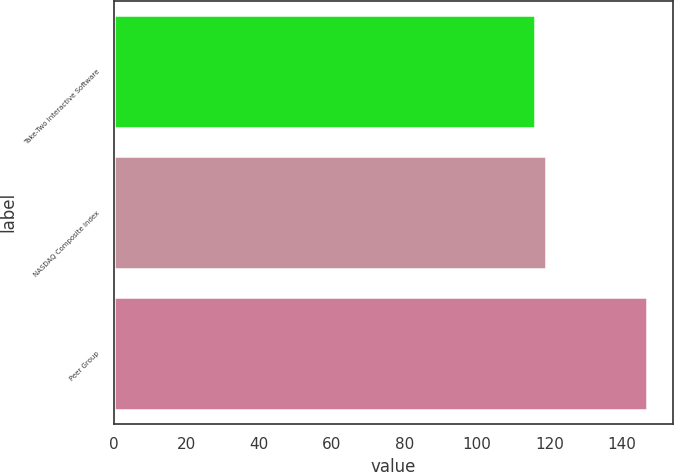<chart> <loc_0><loc_0><loc_500><loc_500><bar_chart><fcel>Take-Two Interactive Software<fcel>NASDAQ Composite Index<fcel>Peer Group<nl><fcel>116.1<fcel>119.17<fcel>146.81<nl></chart> 